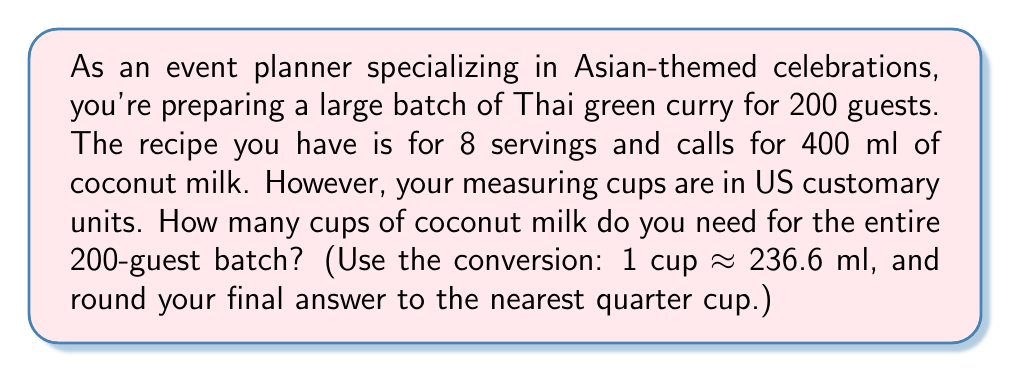Give your solution to this math problem. Let's break this down step-by-step:

1. Calculate the scale factor:
   $\text{Scale factor} = \frac{200 \text{ guests}}{8 \text{ servings}} = 25$

2. Calculate the total amount of coconut milk needed in ml:
   $400 \text{ ml} \times 25 = 10,000 \text{ ml}$

3. Convert ml to cups:
   $$\begin{align*}
   \text{Cups} &= \frac{10,000 \text{ ml}}{236.6 \text{ ml/cup}} \\
   &\approx 42.2655 \text{ cups}
   \end{align*}$$

4. Round to the nearest quarter cup:
   42.2655 cups is closest to 42.25 cups, which is 42 1/4 cups.
Answer: $42\frac{1}{4}$ cups 